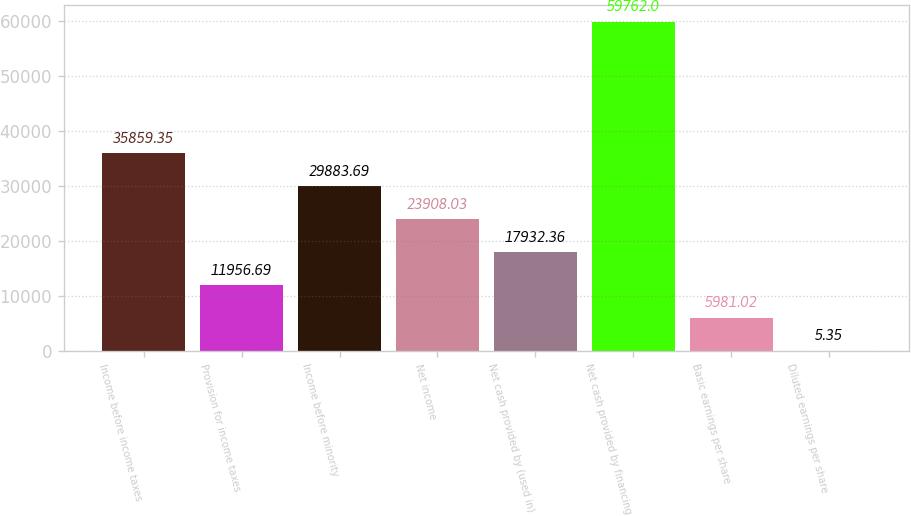Convert chart. <chart><loc_0><loc_0><loc_500><loc_500><bar_chart><fcel>Income before income taxes<fcel>Provision for income taxes<fcel>Income before minority<fcel>Net income<fcel>Net cash provided by (used in)<fcel>Net cash provided by financing<fcel>Basic earnings per share<fcel>Diluted earnings per share<nl><fcel>35859.3<fcel>11956.7<fcel>29883.7<fcel>23908<fcel>17932.4<fcel>59762<fcel>5981.02<fcel>5.35<nl></chart> 